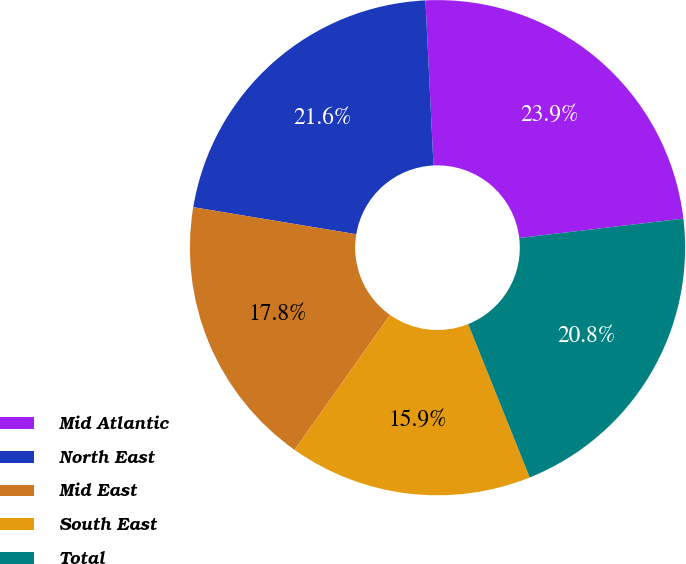Convert chart to OTSL. <chart><loc_0><loc_0><loc_500><loc_500><pie_chart><fcel>Mid Atlantic<fcel>North East<fcel>Mid East<fcel>South East<fcel>Total<nl><fcel>23.9%<fcel>21.61%<fcel>17.82%<fcel>15.87%<fcel>20.8%<nl></chart> 